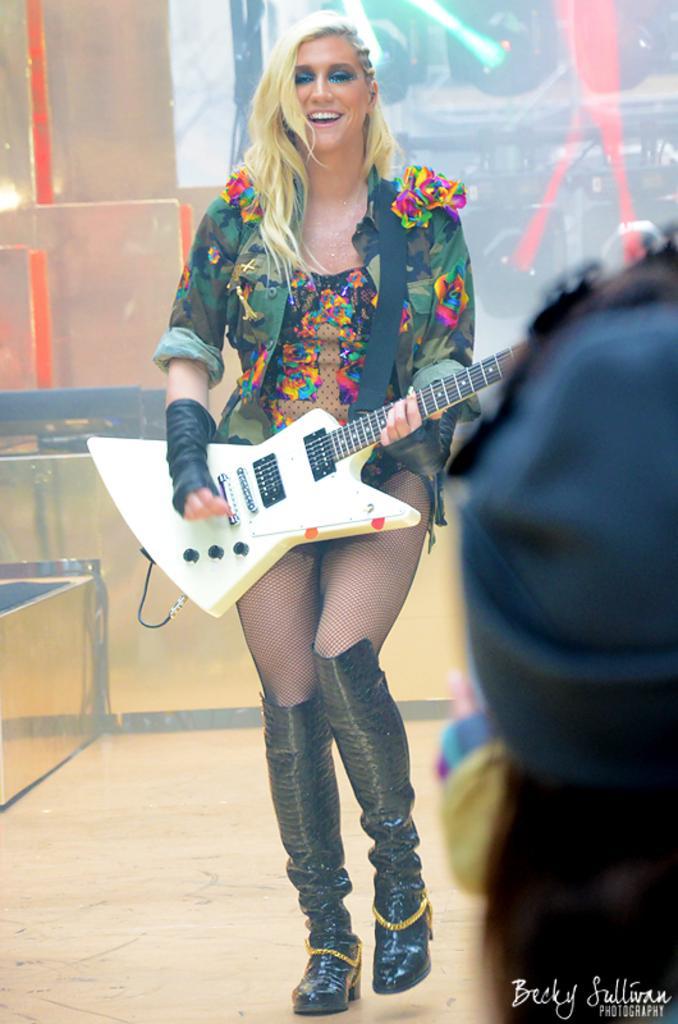Could you give a brief overview of what you see in this image? In this image I can see a woman is playing a guitar. In the background of the image there are focusing lights and objects. At the bottom right side of the image there is a watermark and an object. 